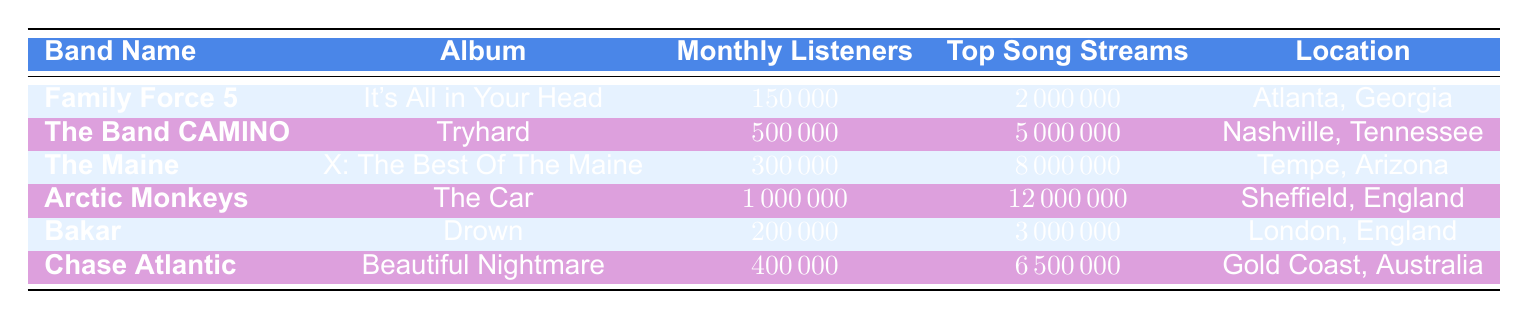What's the release date of Family Force 5's album? The release date for Family Force 5's album "It's All in Your Head" is clearly stated in the table as 2023-09-15.
Answer: 2023-09-15 Which band has the highest number of monthly listeners? By reviewing the monthly listeners for each band in the table, Arctic Monkeys have 1,000,000 monthly listeners, which is the highest compared to the other bands listed.
Answer: Arctic Monkeys How many total streams does The Maine's top song have? The table indicates that The Maine's top song has a total of 8,000,000 streams. This value is pulled directly from the "Top Song Streams" column for The Maine.
Answer: 8000000 Is there a band located in London? From the table, Bakar is the only band listed that is located in London, confirming that there is indeed a band from that location.
Answer: Yes What is the difference in monthly listeners between The Band CAMINO and Chase Atlantic? To find the difference, we subtract Chase Atlantic's monthly listeners (400,000) from The Band CAMINO's (500,000): 500,000 - 400,000 = 100,000. This calculation reveals that The Band CAMINO has 100,000 more monthly listeners than Chase Atlantic.
Answer: 100000 What is the average number of top song streams among all bands listed? First, we add the top song streams for all bands: 2,000,000 + 5,000,000 + 8,000,000 + 12,000,000 + 3,000,000 + 6,500,000 = 36,500,000. Next, we divide by the number of bands (6) to find the average: 36,500,000 / 6 = 6,083,333.33, which rounds to 6,083,333.
Answer: 6083333.33 Which band has the most social media followers combined across Instagram, Twitter, and Facebook? By calculating the total social media followers for each band, we find: Family Force 5 (70,000 + 30,000 + 25,000 = 125,000), The Band CAMINO (150,000 + 45,000 + 60,000 = 255,000), The Maine (120,000 + 50,000 + 70,000 = 240,000), Arctic Monkeys (80,000 + 60,000 + 90,000 = 230,000), Bakar (67,000 + 20,000 + 15,000 = 102,000), Chase Atlantic (300,000 + 80,000 + 30,000 = 410,000). The highest count comes from Chase Atlantic with 410,000 total followers.
Answer: Chase Atlantic Was Family Force 5's album released after The Maine's album? Family Force 5 released their album on 2023-09-15, while The Maine released theirs on 2023-07-21. Since September comes after July, Family Force 5's album was indeed released after The Maine's.
Answer: Yes 